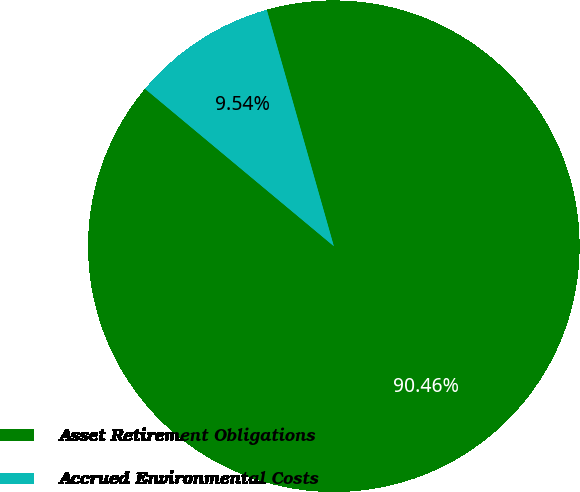<chart> <loc_0><loc_0><loc_500><loc_500><pie_chart><fcel>Asset Retirement Obligations<fcel>Accrued Environmental Costs<nl><fcel>90.46%<fcel>9.54%<nl></chart> 